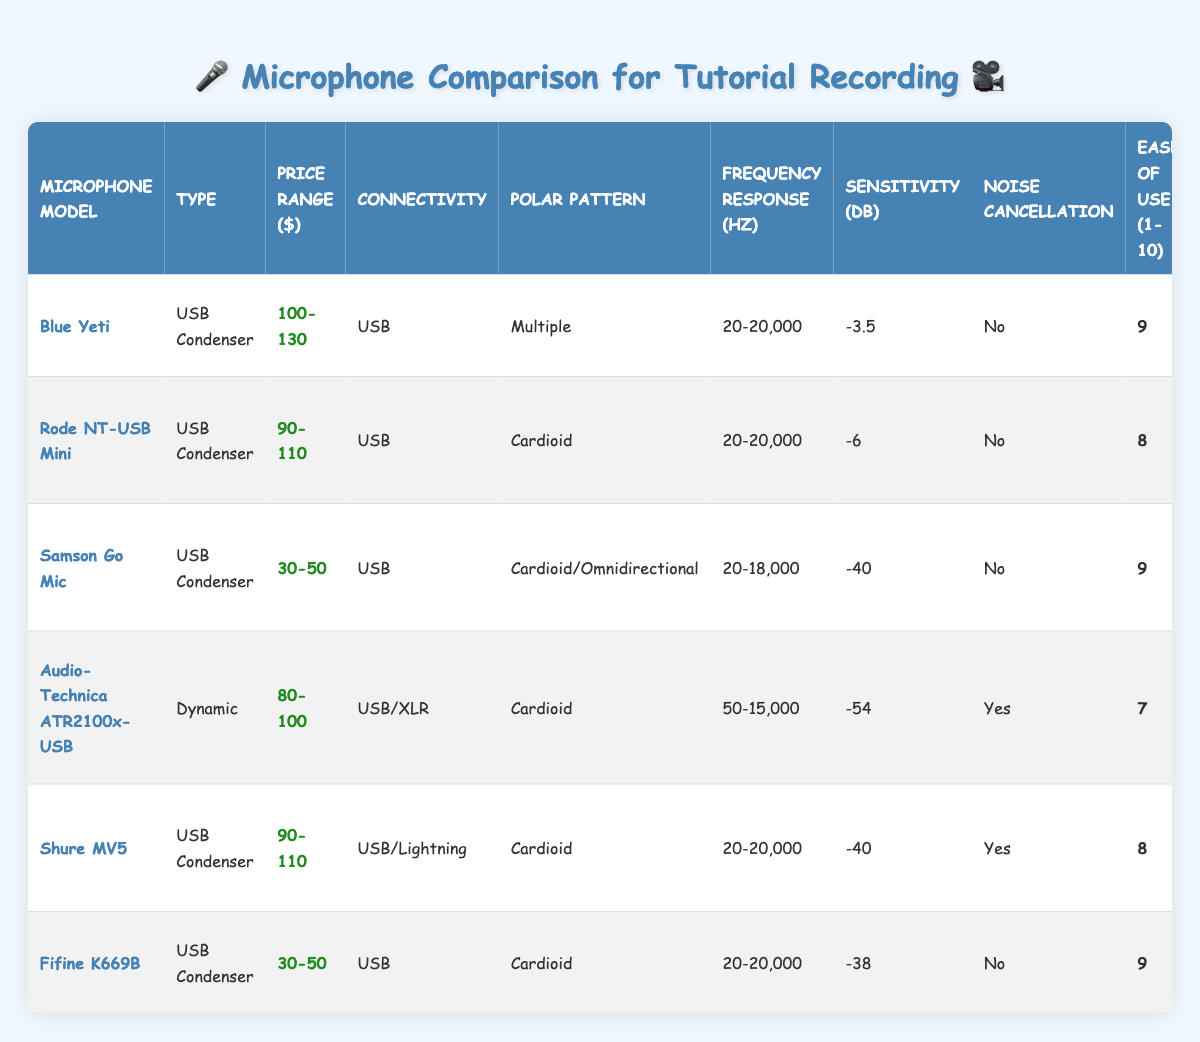What is the price range of the Blue Yeti microphone? The Blue Yeti microphone's price range is directly listed in the table under the "Price Range ($)" column. Referring to the corresponding row for the Blue Yeti, the price range is 100-130.
Answer: 100-130 Which microphone has the highest sensitivity value? To find the highest sensitivity value, I compared the values in the "Sensitivity (dB)" column for all microphones. The value for the Blue Yeti is -3.5, Rode NT-USB Mini is -6, Samson Go Mic -40, Audio-Technica ATR2100x-USB -54, Shure MV5 -40, and Fifine K669B -38. The highest sensitivity value is -3.5 from the Blue Yeti.
Answer: -3.5 Is the Rode NT-USB Mini suitable for online teaching? The suitability of the Rode NT-USB Mini is listed in the "Suitable for" column. It clearly mentions "Portable recording, Online teaching," confirming this microphone's fit for online teaching.
Answer: Yes What is the average ease of use rating for the microphones? To calculate the average ease of use, I first add the ease of use ratings: 9 + 8 + 9 + 7 + 8 + 9 = 50. Since there are 6 microphones, I divide the total by 6: 50 / 6 = 8.33. The average rating is approximately 8.33.
Answer: 8.33 Which microphones have noise cancellation? I need to look at the "Noise Cancellation" column and check which ones indicate "Yes." The Audio-Technica ATR2100x-USB and Shure MV5 are marked as having noise cancellation, while the others do not.
Answer: Audio-Technica ATR2100x-USB, Shure MV5 What is the frequency response range for the Samson Go Mic? The frequency response for the Samson Go Mic is directly found in the "Frequency Response (Hz)" column. The table shows that it has a frequency response range of 20-18,000 Hz.
Answer: 20-18,000 Hz How many microphones are there that fall into the price range of 30-50 dollars? I refer to the "Price Range ($)" column and check for the values that fall between 30-50 dollars. The Samson Go Mic and Fifine K669B both fit within this range, making a total of 2 microphones in this price range.
Answer: 2 Which microphone is best for beginners according to the table? To determine which microphone is best for beginners, I look at the "Easy of Use (1-10)" column and the "Suitable for" column. The Fifine K669B has a high ease of use rating of 9 and is specifically marked as "Budget-friendly, Beginners," making it the best option for beginners.
Answer: Fifine K669B 